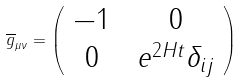<formula> <loc_0><loc_0><loc_500><loc_500>\overline { g } _ { \mu \nu } = \left ( \begin{array} { c c } { - 1 \, } & { \, 0 } \\ { 0 \, } & { { \, e ^ { 2 H t } \delta _ { i j } } } \end{array} \right )</formula> 